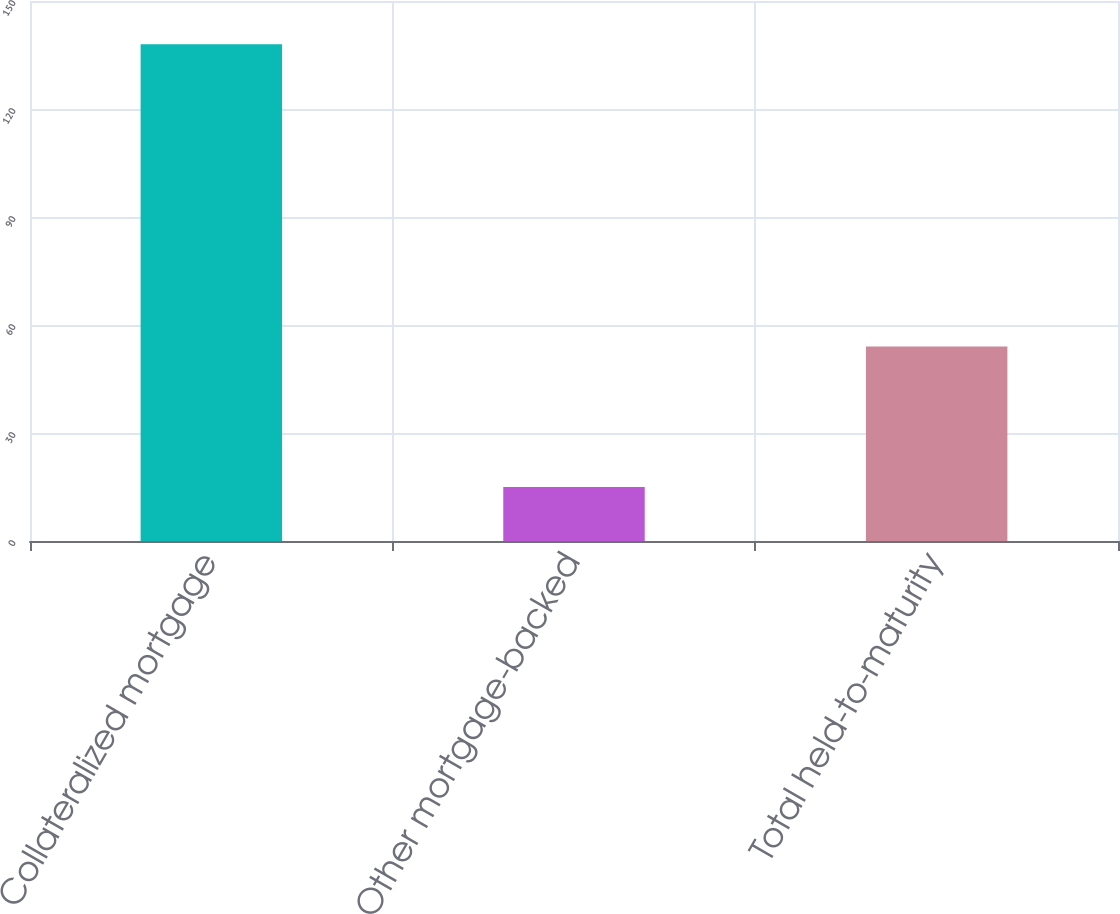Convert chart. <chart><loc_0><loc_0><loc_500><loc_500><bar_chart><fcel>Collateralized mortgage<fcel>Other mortgage-backed<fcel>Total held-to-maturity<nl><fcel>138<fcel>15<fcel>54<nl></chart> 